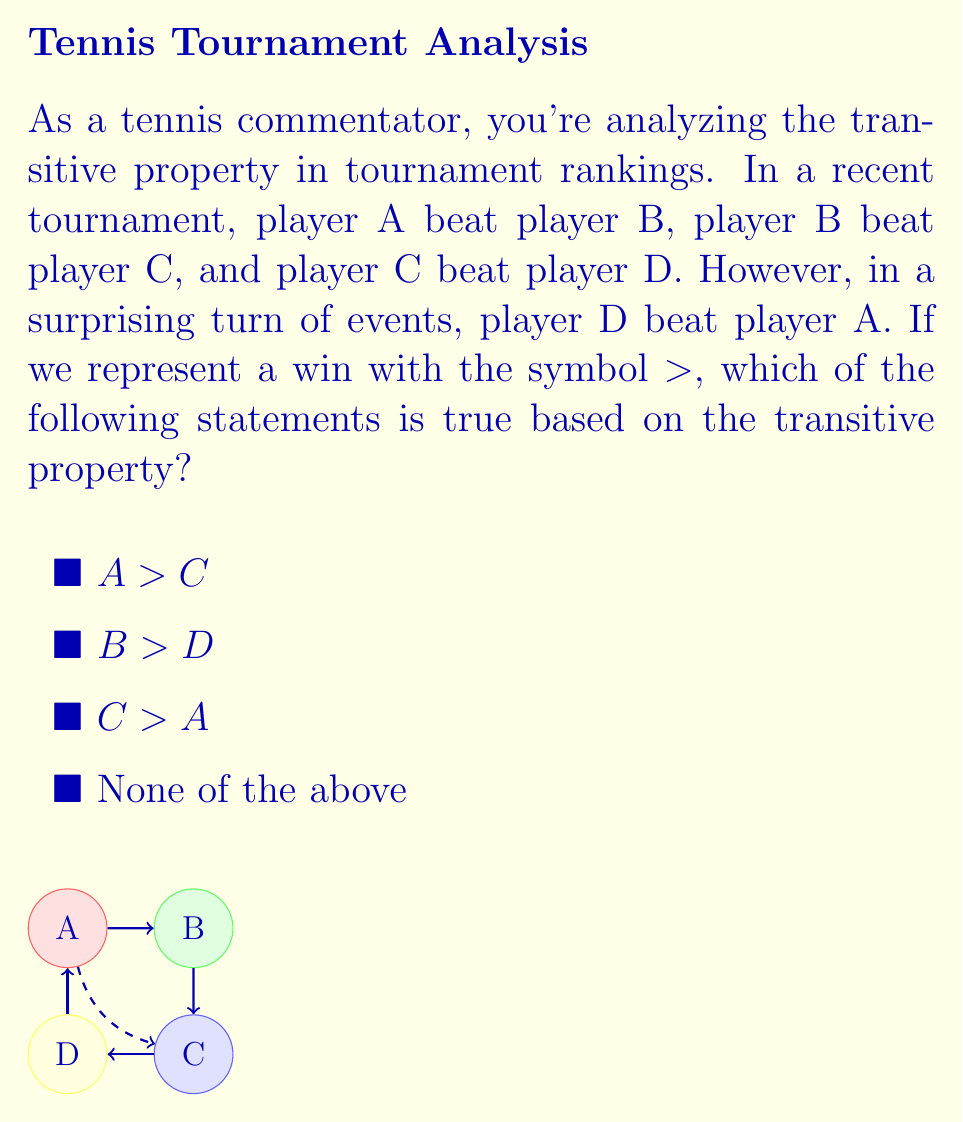Can you solve this math problem? Let's analyze this step-by-step:

1) The transitive property in mathematics states that if $a > b$ and $b > c$, then $a > c$.

2) From the given information:
   $A > B$
   $B > C$
   $C > D$
   $D > A$

3) Applying the transitive property to the first two statements:
   If $A > B$ and $B > C$, then $A > C$

4) This means statement 1 ($A > C$) is true based on the transitive property.

5) For statement 2 ($B > D$):
   We know $B > C$ and $C > D$, so by the transitive property, $B > D$ is also true.

6) For statement 3 ($C > A$):
   We don't have direct information to conclude this. The given information actually suggests the opposite ($A > C$).

7) The fact that $D > A$ creates a circular relationship, which is why rankings can sometimes be counterintuitive in tennis and other sports.

Therefore, both statements 1 and 2 are true based on the transitive property.
Answer: 2) $B > D$ 